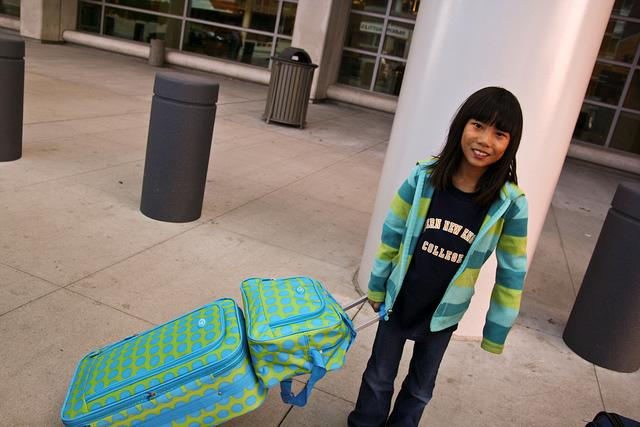Upon which vessel might this person go for a ride soon? airplane 